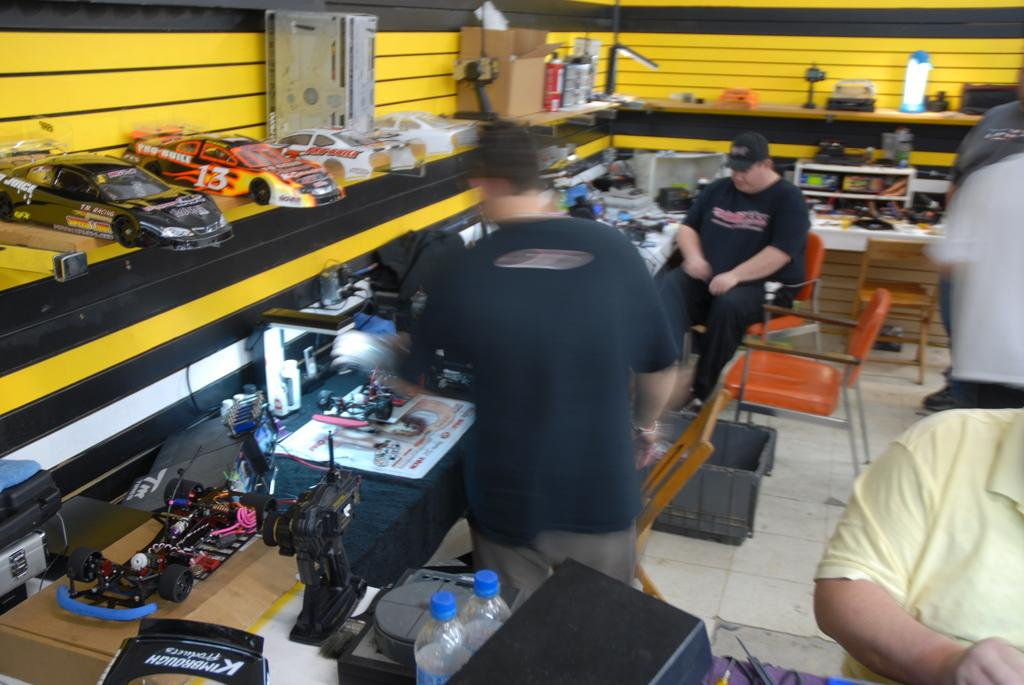What is the main subject of the image? There is a man standing in the middle of the image. What is the man wearing? The man is wearing a black t-shirt. Can you describe the other person in the image? There is another person sitting on a chair in the image. What can be seen on the left side of the image? There are toy cars on the left side of the image. What type of liquid is being poured out of the man's mouth in the image? There is no liquid being poured out of the man's mouth in the image, as this is not mentioned in the provided facts. 